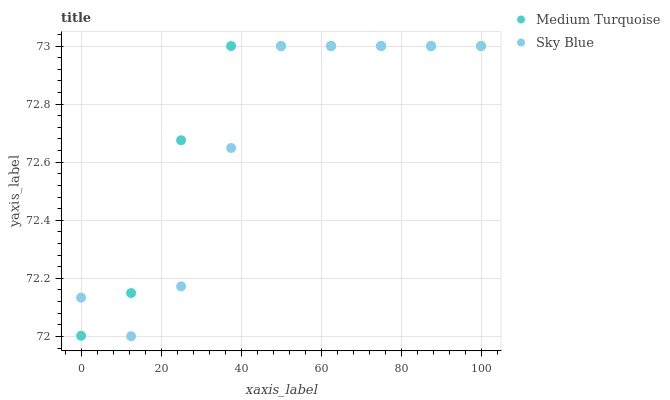Does Sky Blue have the minimum area under the curve?
Answer yes or no. Yes. Does Medium Turquoise have the maximum area under the curve?
Answer yes or no. Yes. Does Medium Turquoise have the minimum area under the curve?
Answer yes or no. No. Is Medium Turquoise the smoothest?
Answer yes or no. Yes. Is Sky Blue the roughest?
Answer yes or no. Yes. Is Medium Turquoise the roughest?
Answer yes or no. No. Does Sky Blue have the lowest value?
Answer yes or no. Yes. Does Medium Turquoise have the lowest value?
Answer yes or no. No. Does Medium Turquoise have the highest value?
Answer yes or no. Yes. Does Sky Blue intersect Medium Turquoise?
Answer yes or no. Yes. Is Sky Blue less than Medium Turquoise?
Answer yes or no. No. Is Sky Blue greater than Medium Turquoise?
Answer yes or no. No. 